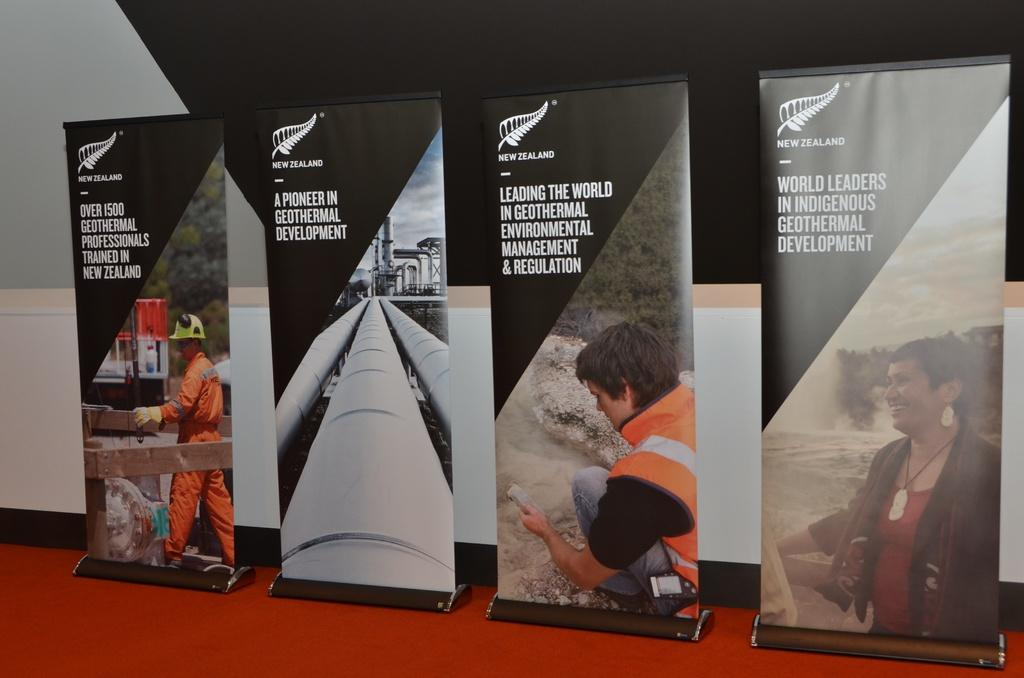<image>
Render a clear and concise summary of the photo. New Zealand geothermal adverts are shown on these four banners. 